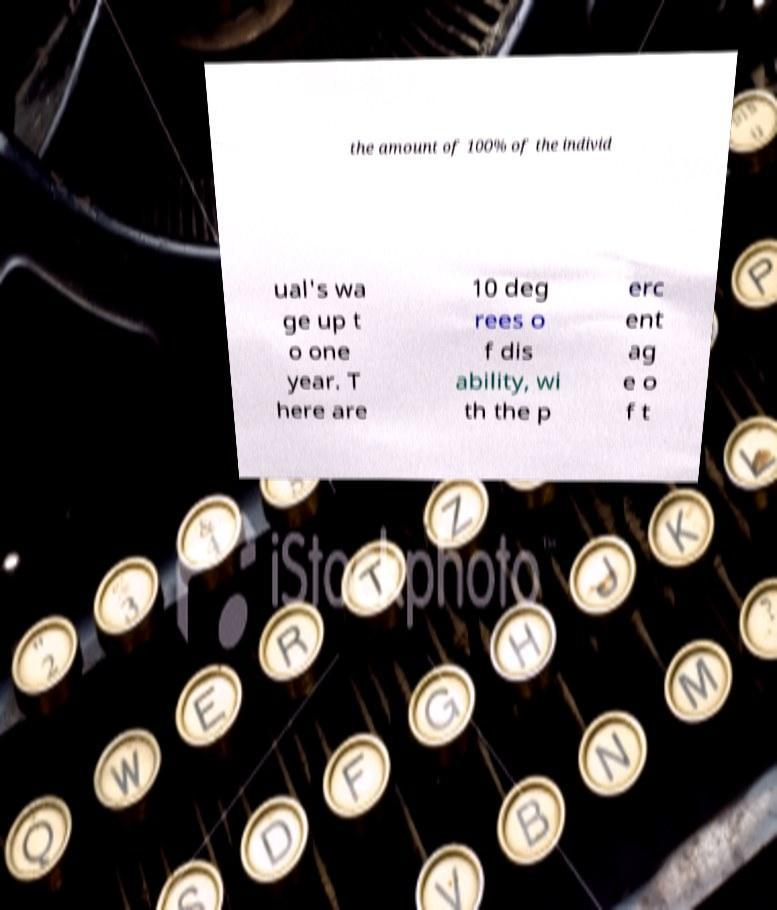Please read and relay the text visible in this image. What does it say? the amount of 100% of the individ ual's wa ge up t o one year. T here are 10 deg rees o f dis ability, wi th the p erc ent ag e o f t 